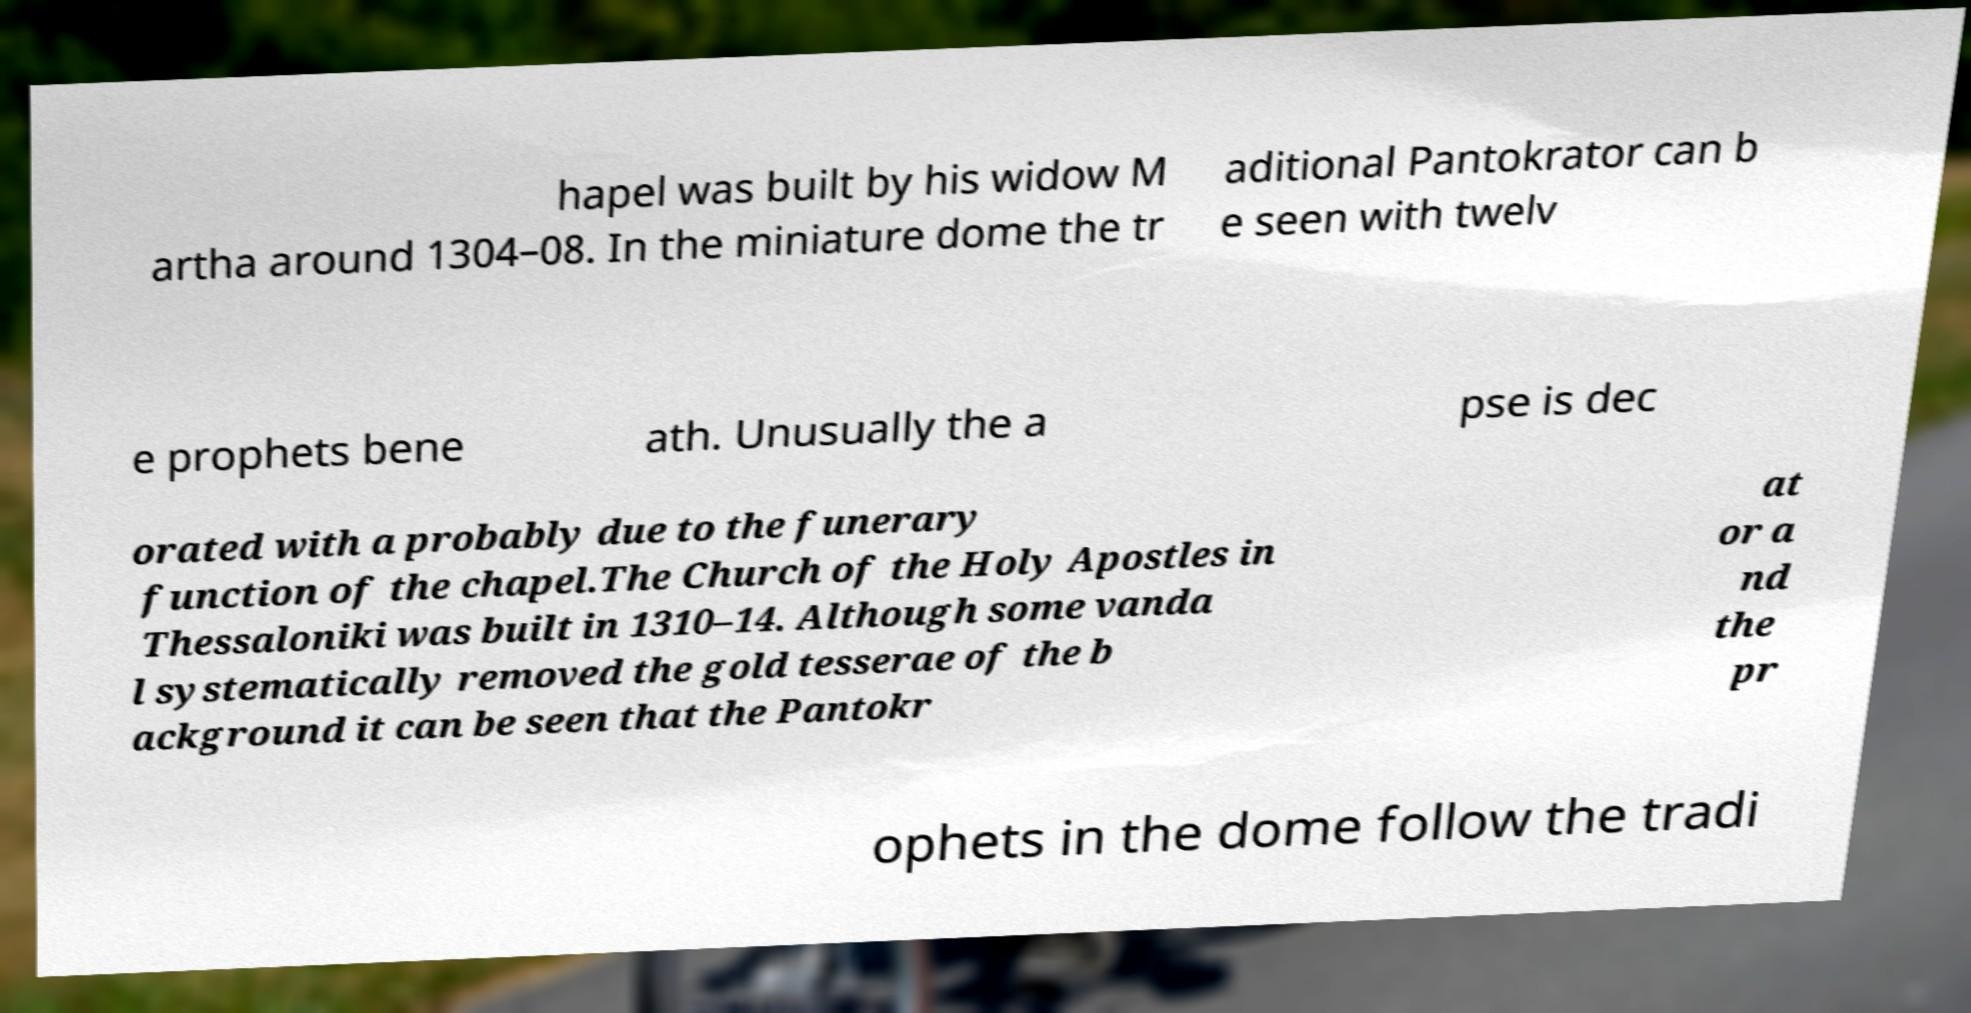Could you extract and type out the text from this image? hapel was built by his widow M artha around 1304–08. In the miniature dome the tr aditional Pantokrator can b e seen with twelv e prophets bene ath. Unusually the a pse is dec orated with a probably due to the funerary function of the chapel.The Church of the Holy Apostles in Thessaloniki was built in 1310–14. Although some vanda l systematically removed the gold tesserae of the b ackground it can be seen that the Pantokr at or a nd the pr ophets in the dome follow the tradi 